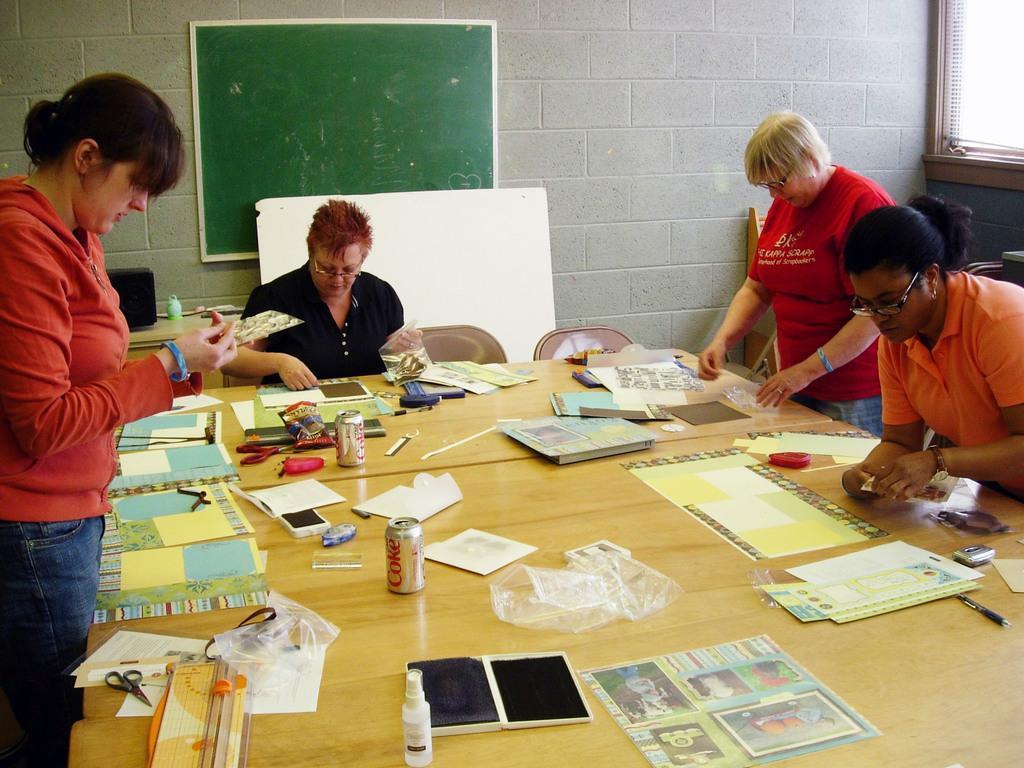How would you summarize this image in a sentence or two? in the picture we can see women doing some work,with the table in front of them,in the table there are different materials of paper,scissors,cover,glue bottles and e. t. c., here we can sees a board on the wall ,here we can also see the chair,here we can see a window near to the wall,here the women are doing some work with that material. 